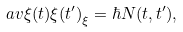<formula> <loc_0><loc_0><loc_500><loc_500>\ a v { \xi ( t ) \xi ( t ^ { \prime } ) } _ { \xi } = \hbar { N } ( t , t ^ { \prime } ) ,</formula> 